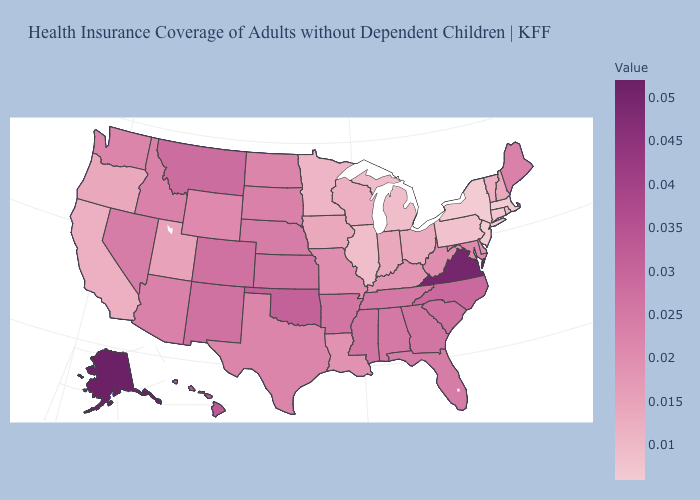Does Massachusetts have the lowest value in the USA?
Concise answer only. Yes. Among the states that border Connecticut , does Rhode Island have the highest value?
Give a very brief answer. Yes. Does Alabama have a lower value than Oklahoma?
Concise answer only. Yes. Which states hav the highest value in the West?
Write a very short answer. Alaska. Which states hav the highest value in the West?
Write a very short answer. Alaska. Among the states that border Virginia , does Kentucky have the lowest value?
Give a very brief answer. Yes. Does New Hampshire have the lowest value in the Northeast?
Be succinct. No. 